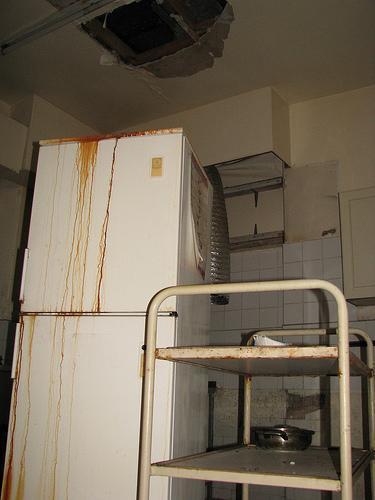How many pans are in the photo?
Give a very brief answer. 1. How many handles are on the front of the refrigerator?
Give a very brief answer. 2. How many shelves have a visible pot on them?
Give a very brief answer. 1. 